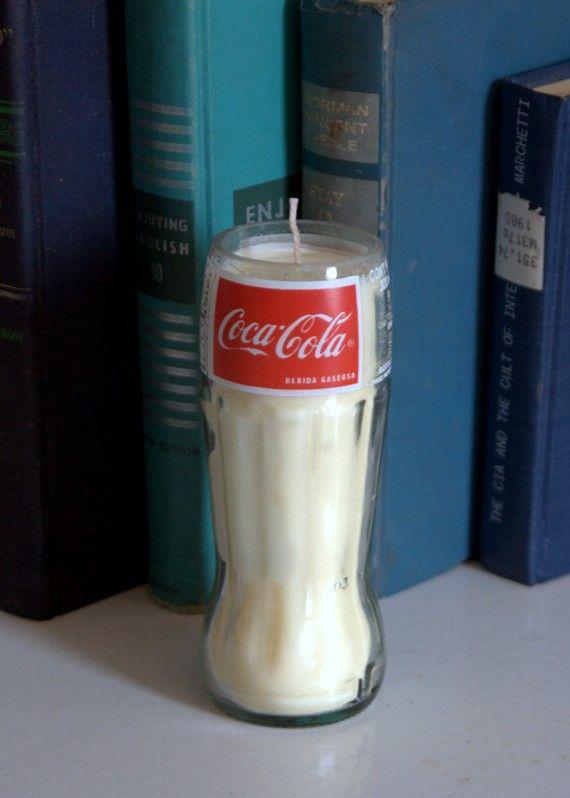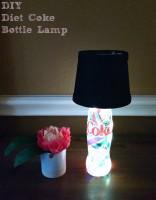The first image is the image on the left, the second image is the image on the right. Given the left and right images, does the statement "One image includes at least one candle with a wick in an upright glass soda bottle with a red label and its neck cut off." hold true? Answer yes or no. Yes. The first image is the image on the left, the second image is the image on the right. For the images shown, is this caption "The left and right image contains the same number of glass containers shaped like a bottle." true? Answer yes or no. Yes. 